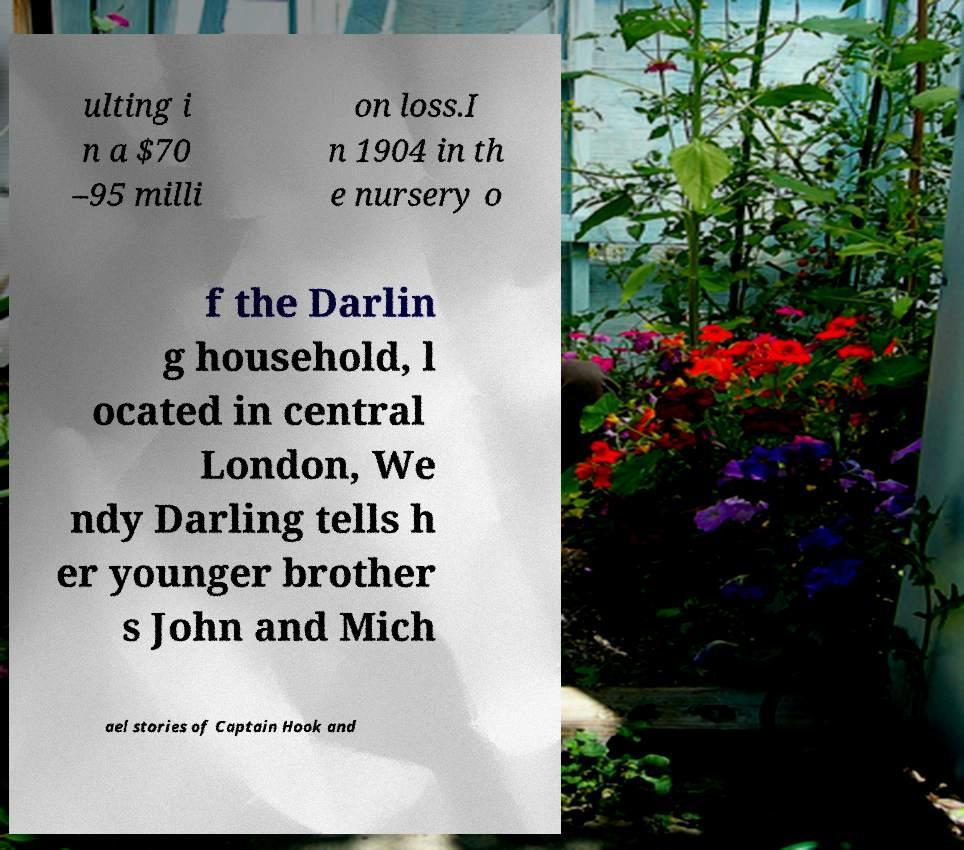Please identify and transcribe the text found in this image. ulting i n a $70 –95 milli on loss.I n 1904 in th e nursery o f the Darlin g household, l ocated in central London, We ndy Darling tells h er younger brother s John and Mich ael stories of Captain Hook and 